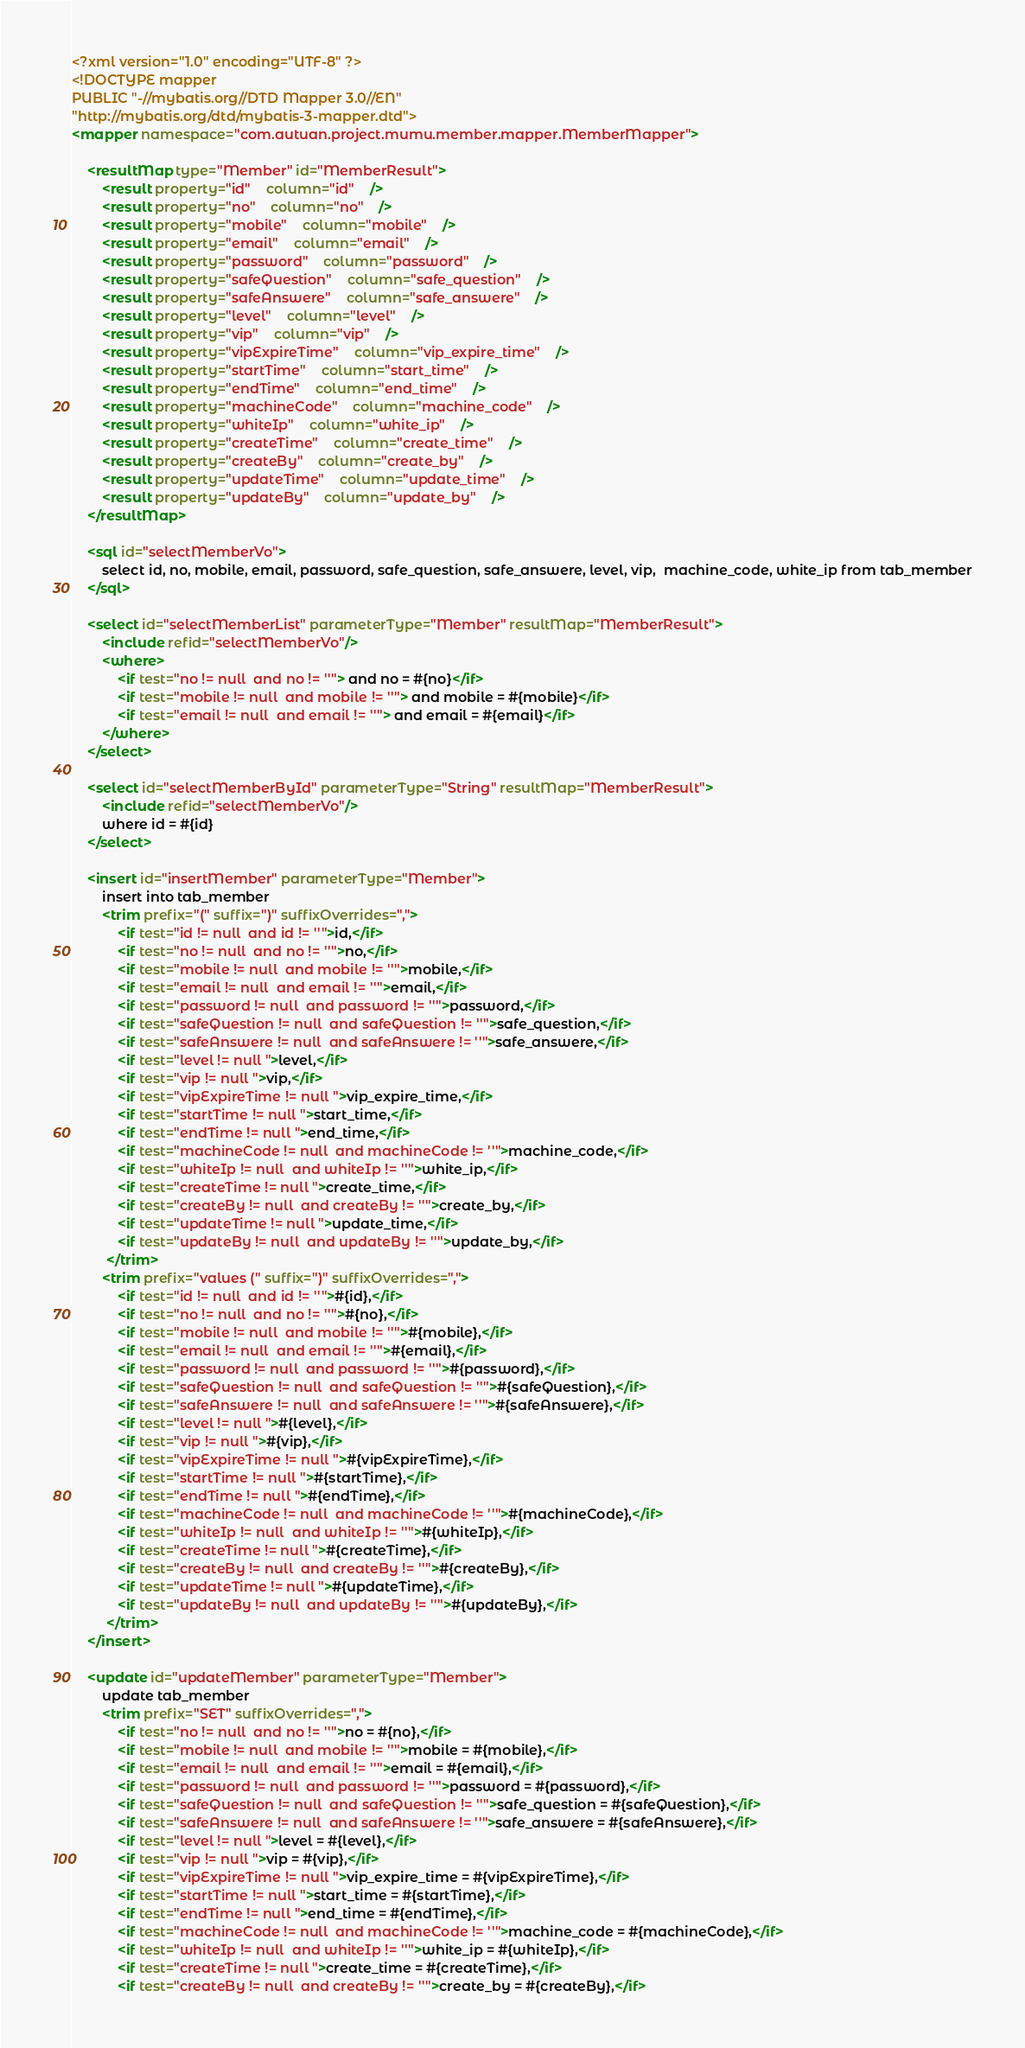Convert code to text. <code><loc_0><loc_0><loc_500><loc_500><_XML_><?xml version="1.0" encoding="UTF-8" ?>
<!DOCTYPE mapper
PUBLIC "-//mybatis.org//DTD Mapper 3.0//EN"
"http://mybatis.org/dtd/mybatis-3-mapper.dtd">
<mapper namespace="com.autuan.project.mumu.member.mapper.MemberMapper">
    
    <resultMap type="Member" id="MemberResult">
        <result property="id"    column="id"    />
        <result property="no"    column="no"    />
        <result property="mobile"    column="mobile"    />
        <result property="email"    column="email"    />
        <result property="password"    column="password"    />
        <result property="safeQuestion"    column="safe_question"    />
        <result property="safeAnswere"    column="safe_answere"    />
        <result property="level"    column="level"    />
        <result property="vip"    column="vip"    />
        <result property="vipExpireTime"    column="vip_expire_time"    />
        <result property="startTime"    column="start_time"    />
        <result property="endTime"    column="end_time"    />
        <result property="machineCode"    column="machine_code"    />
        <result property="whiteIp"    column="white_ip"    />
        <result property="createTime"    column="create_time"    />
        <result property="createBy"    column="create_by"    />
        <result property="updateTime"    column="update_time"    />
        <result property="updateBy"    column="update_by"    />
    </resultMap>

    <sql id="selectMemberVo">
        select id, no, mobile, email, password, safe_question, safe_answere, level, vip,  machine_code, white_ip from tab_member
    </sql>

    <select id="selectMemberList" parameterType="Member" resultMap="MemberResult">
        <include refid="selectMemberVo"/>
        <where>  
            <if test="no != null  and no != ''"> and no = #{no}</if>
            <if test="mobile != null  and mobile != ''"> and mobile = #{mobile}</if>
            <if test="email != null  and email != ''"> and email = #{email}</if>
        </where>
    </select>
    
    <select id="selectMemberById" parameterType="String" resultMap="MemberResult">
        <include refid="selectMemberVo"/>
        where id = #{id}
    </select>
        
    <insert id="insertMember" parameterType="Member">
        insert into tab_member
        <trim prefix="(" suffix=")" suffixOverrides=",">
            <if test="id != null  and id != ''">id,</if>
            <if test="no != null  and no != ''">no,</if>
            <if test="mobile != null  and mobile != ''">mobile,</if>
            <if test="email != null  and email != ''">email,</if>
            <if test="password != null  and password != ''">password,</if>
            <if test="safeQuestion != null  and safeQuestion != ''">safe_question,</if>
            <if test="safeAnswere != null  and safeAnswere != ''">safe_answere,</if>
            <if test="level != null ">level,</if>
            <if test="vip != null ">vip,</if>
            <if test="vipExpireTime != null ">vip_expire_time,</if>
            <if test="startTime != null ">start_time,</if>
            <if test="endTime != null ">end_time,</if>
            <if test="machineCode != null  and machineCode != ''">machine_code,</if>
            <if test="whiteIp != null  and whiteIp != ''">white_ip,</if>
            <if test="createTime != null ">create_time,</if>
            <if test="createBy != null  and createBy != ''">create_by,</if>
            <if test="updateTime != null ">update_time,</if>
            <if test="updateBy != null  and updateBy != ''">update_by,</if>
         </trim>
        <trim prefix="values (" suffix=")" suffixOverrides=",">
            <if test="id != null  and id != ''">#{id},</if>
            <if test="no != null  and no != ''">#{no},</if>
            <if test="mobile != null  and mobile != ''">#{mobile},</if>
            <if test="email != null  and email != ''">#{email},</if>
            <if test="password != null  and password != ''">#{password},</if>
            <if test="safeQuestion != null  and safeQuestion != ''">#{safeQuestion},</if>
            <if test="safeAnswere != null  and safeAnswere != ''">#{safeAnswere},</if>
            <if test="level != null ">#{level},</if>
            <if test="vip != null ">#{vip},</if>
            <if test="vipExpireTime != null ">#{vipExpireTime},</if>
            <if test="startTime != null ">#{startTime},</if>
            <if test="endTime != null ">#{endTime},</if>
            <if test="machineCode != null  and machineCode != ''">#{machineCode},</if>
            <if test="whiteIp != null  and whiteIp != ''">#{whiteIp},</if>
            <if test="createTime != null ">#{createTime},</if>
            <if test="createBy != null  and createBy != ''">#{createBy},</if>
            <if test="updateTime != null ">#{updateTime},</if>
            <if test="updateBy != null  and updateBy != ''">#{updateBy},</if>
         </trim>
    </insert>

    <update id="updateMember" parameterType="Member">
        update tab_member
        <trim prefix="SET" suffixOverrides=",">
            <if test="no != null  and no != ''">no = #{no},</if>
            <if test="mobile != null  and mobile != ''">mobile = #{mobile},</if>
            <if test="email != null  and email != ''">email = #{email},</if>
            <if test="password != null  and password != ''">password = #{password},</if>
            <if test="safeQuestion != null  and safeQuestion != ''">safe_question = #{safeQuestion},</if>
            <if test="safeAnswere != null  and safeAnswere != ''">safe_answere = #{safeAnswere},</if>
            <if test="level != null ">level = #{level},</if>
            <if test="vip != null ">vip = #{vip},</if>
            <if test="vipExpireTime != null ">vip_expire_time = #{vipExpireTime},</if>
            <if test="startTime != null ">start_time = #{startTime},</if>
            <if test="endTime != null ">end_time = #{endTime},</if>
            <if test="machineCode != null  and machineCode != ''">machine_code = #{machineCode},</if>
            <if test="whiteIp != null  and whiteIp != ''">white_ip = #{whiteIp},</if>
            <if test="createTime != null ">create_time = #{createTime},</if>
            <if test="createBy != null  and createBy != ''">create_by = #{createBy},</if></code> 